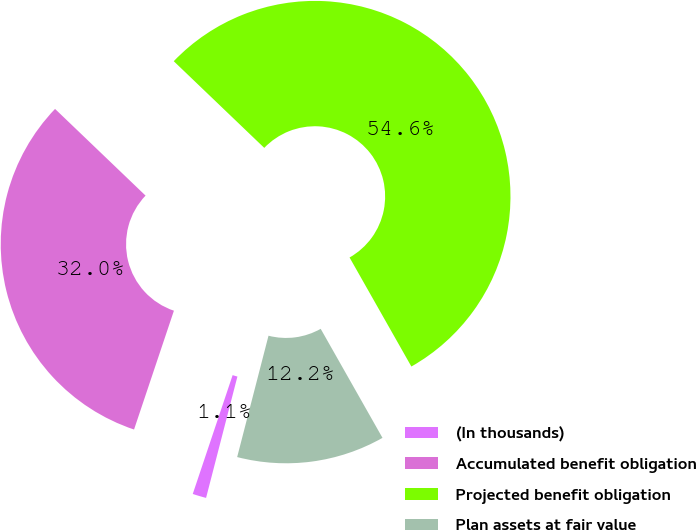Convert chart to OTSL. <chart><loc_0><loc_0><loc_500><loc_500><pie_chart><fcel>(In thousands)<fcel>Accumulated benefit obligation<fcel>Projected benefit obligation<fcel>Plan assets at fair value<nl><fcel>1.13%<fcel>32.0%<fcel>54.63%<fcel>12.23%<nl></chart> 